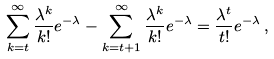Convert formula to latex. <formula><loc_0><loc_0><loc_500><loc_500>\sum _ { k = t } ^ { \infty } \frac { \lambda ^ { k } } { k ! } e ^ { - \lambda } - \sum _ { k = t + 1 } ^ { \infty } \frac { \lambda ^ { k } } { k ! } e ^ { - \lambda } = \frac { \lambda ^ { t } } { t ! } e ^ { - \lambda } \, ,</formula> 